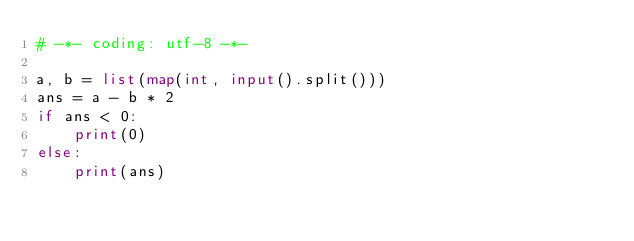<code> <loc_0><loc_0><loc_500><loc_500><_Python_># -*- coding: utf-8 -*-

a, b = list(map(int, input().split()))
ans = a - b * 2
if ans < 0:
    print(0)
else:
    print(ans)</code> 